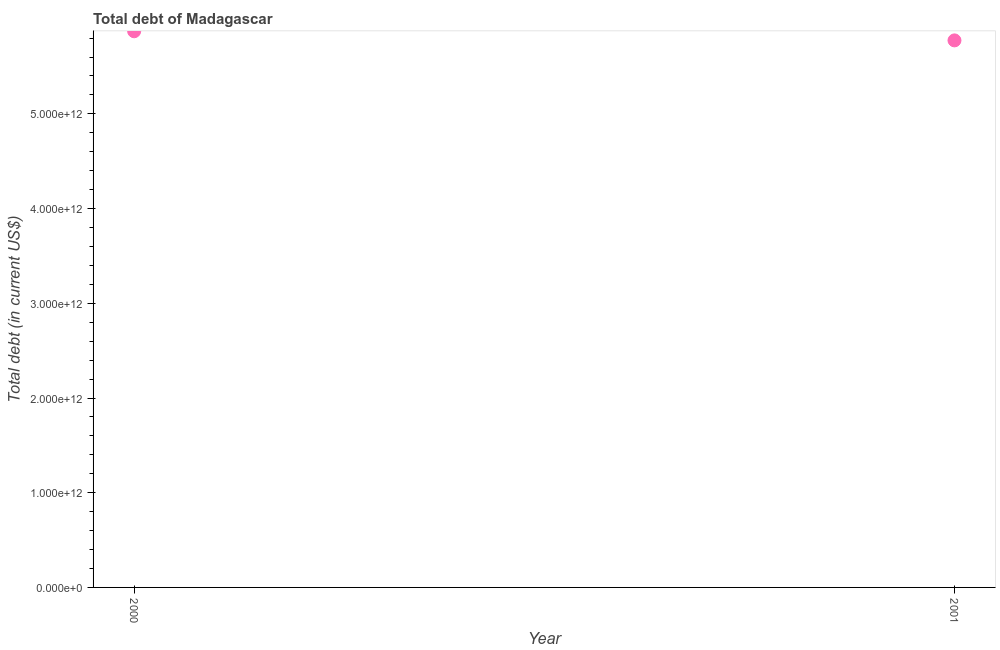What is the total debt in 2000?
Your answer should be very brief. 5.87e+12. Across all years, what is the maximum total debt?
Make the answer very short. 5.87e+12. Across all years, what is the minimum total debt?
Your answer should be very brief. 5.78e+12. In which year was the total debt minimum?
Your answer should be very brief. 2001. What is the sum of the total debt?
Give a very brief answer. 1.16e+13. What is the difference between the total debt in 2000 and 2001?
Your response must be concise. 9.62e+1. What is the average total debt per year?
Your response must be concise. 5.82e+12. What is the median total debt?
Ensure brevity in your answer.  5.82e+12. In how many years, is the total debt greater than 5200000000000 US$?
Offer a terse response. 2. What is the ratio of the total debt in 2000 to that in 2001?
Offer a very short reply. 1.02. Is the total debt in 2000 less than that in 2001?
Your answer should be compact. No. How many dotlines are there?
Keep it short and to the point. 1. What is the difference between two consecutive major ticks on the Y-axis?
Make the answer very short. 1.00e+12. Are the values on the major ticks of Y-axis written in scientific E-notation?
Offer a terse response. Yes. Does the graph contain any zero values?
Keep it short and to the point. No. What is the title of the graph?
Your answer should be compact. Total debt of Madagascar. What is the label or title of the Y-axis?
Provide a short and direct response. Total debt (in current US$). What is the Total debt (in current US$) in 2000?
Make the answer very short. 5.87e+12. What is the Total debt (in current US$) in 2001?
Your answer should be very brief. 5.78e+12. What is the difference between the Total debt (in current US$) in 2000 and 2001?
Your response must be concise. 9.62e+1. 